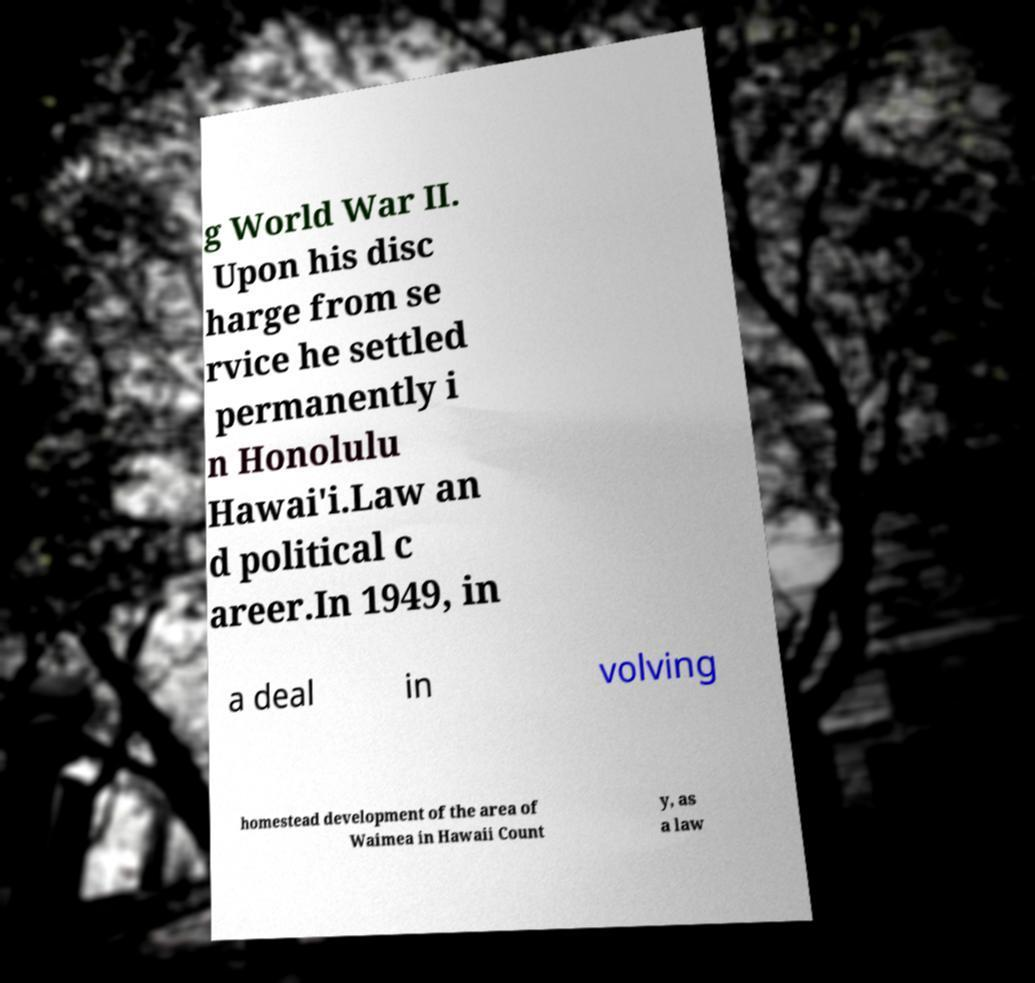Could you extract and type out the text from this image? g World War II. Upon his disc harge from se rvice he settled permanently i n Honolulu Hawai'i.Law an d political c areer.In 1949, in a deal in volving homestead development of the area of Waimea in Hawaii Count y, as a law 